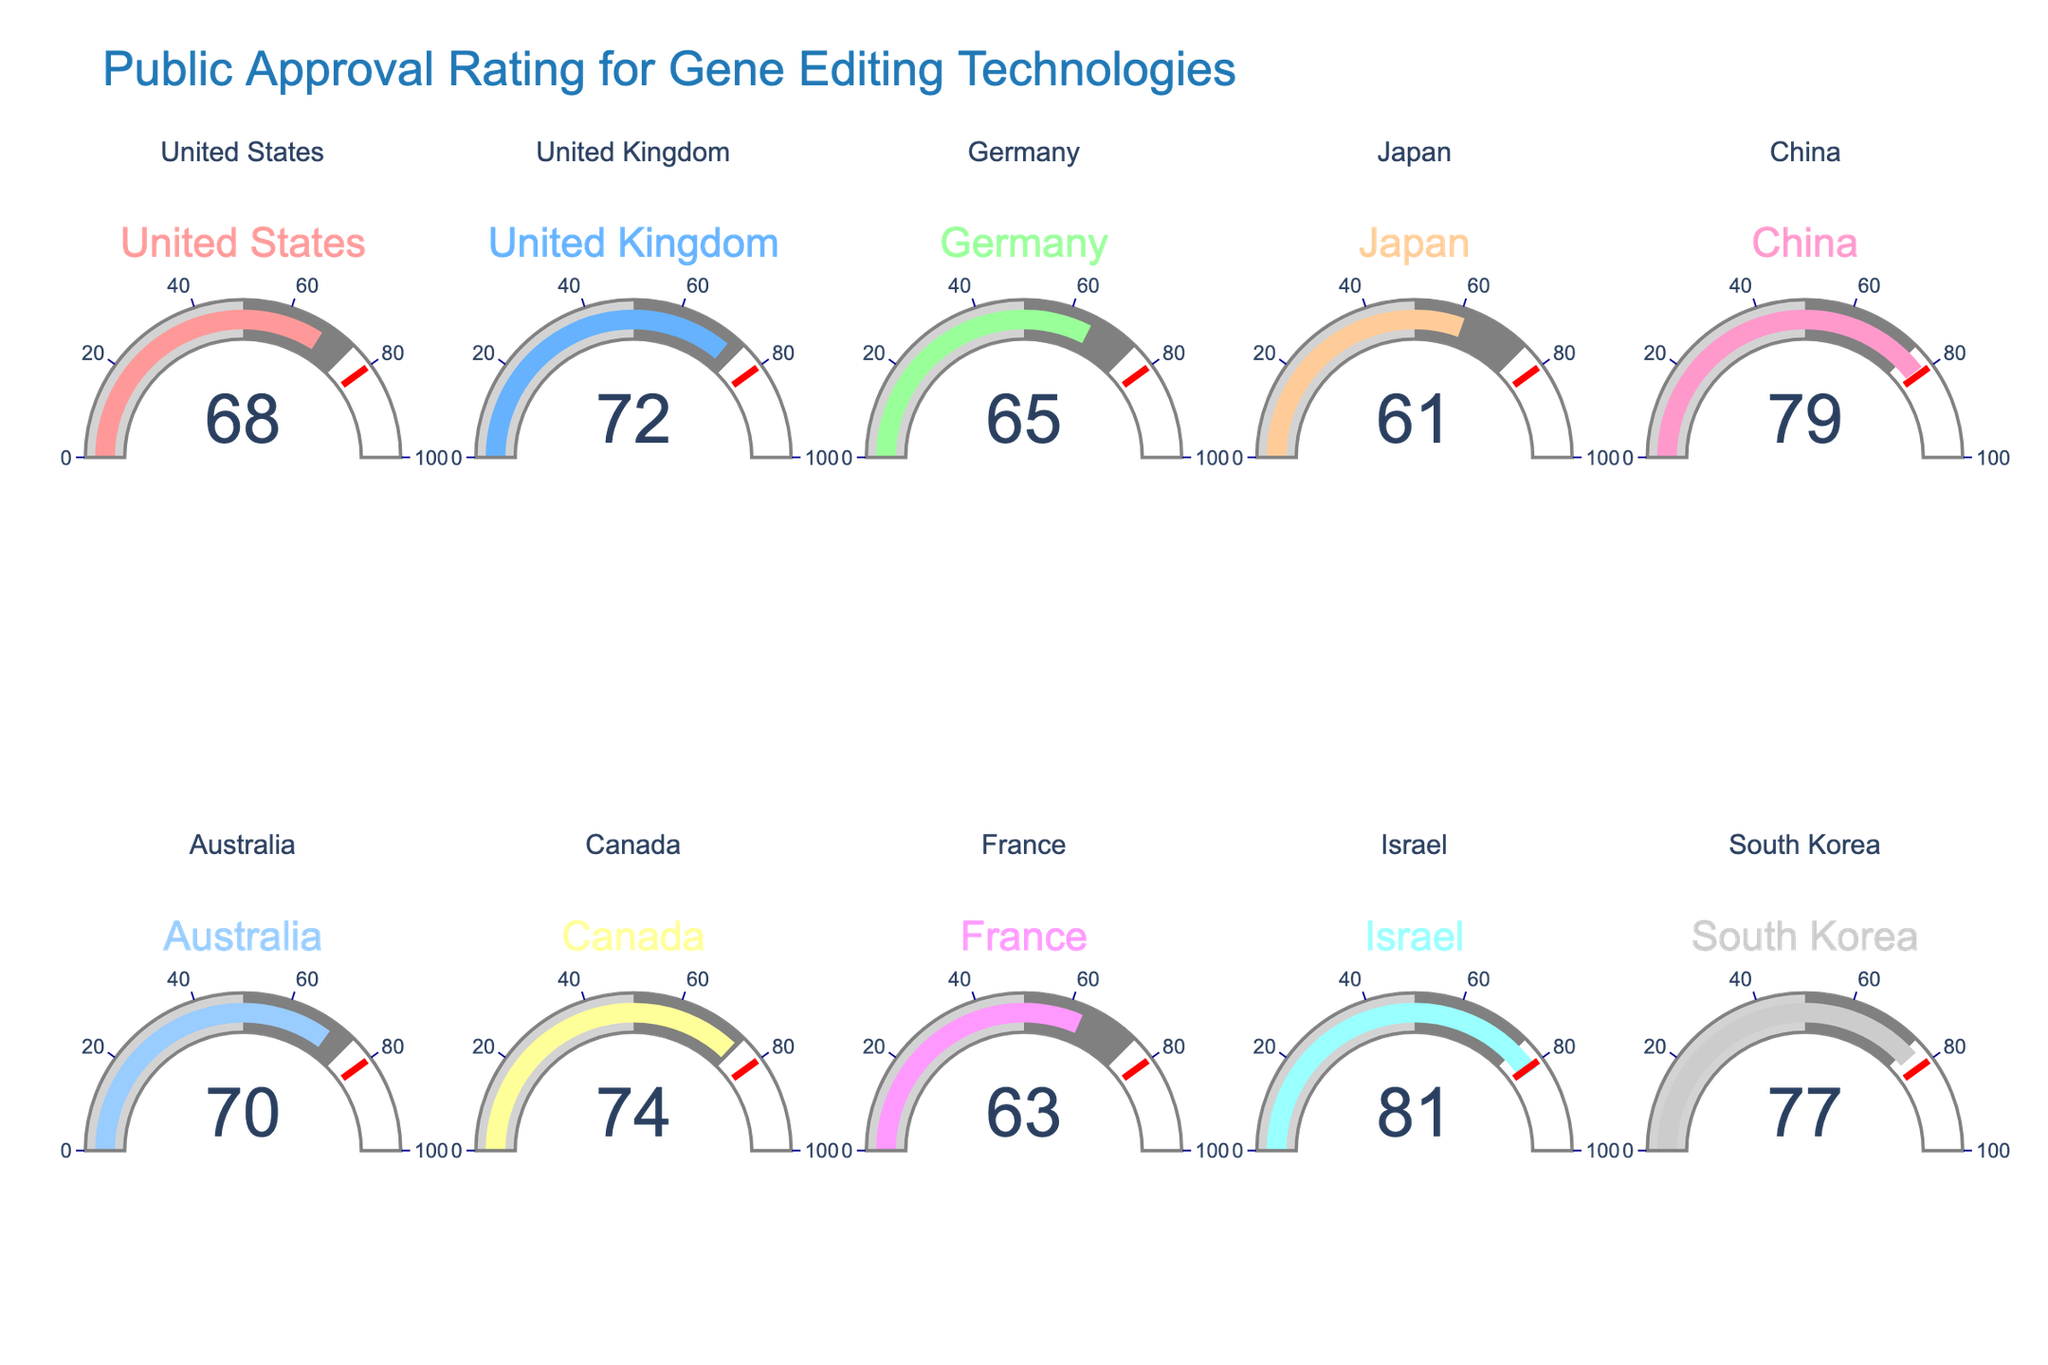What is the approval rating for gene editing technologies in the United States? The gauge for the United States shows a value of 68, representing the approval rating.
Answer: 68 Which country has the highest approval rating for gene editing technologies? By comparing all the gauges, Israel has the highest approval rating with a value of 81.
Answer: Israel What is the average approval rating across all listed countries? Sum of all approval percentages (68+72+65+61+79+70+74+63+81+77) = 710. The number of countries is 10. Average = 710/10 = 71
Answer: 71 How does Germany's approval rating compare to Japan's? Germany's approval rating is 65 while Japan's is 61. Germany's rating is higher.
Answer: Germany's rating is higher Is there any country with an approval rating between 60 and 65? By examining the gauges, Japan (61) and Germany (65) fall within this range.
Answer: Yes, Japan and Germany What is the difference between the highest and the lowest approval ratings? The highest approval rating is from Israel (81) and the lowest is Japan (61). Difference = 81 - 61 = 20
Answer: 20 Which countries have approval ratings above 75? The countries with gauges displaying values higher than 75 are China (79), Israel (81), and South Korea (77).
Answer: China, Israel, South Korea Is Canada's approval rating above or below the average rating? The average rating across all countries is 71. Canada's approval rating is 74, which is above the average.
Answer: Above What is the median approval rating for the listed countries? Ordered ratings: 61, 63, 65, 68, 70, 72, 74, 77, 79, 81. With 10 data points, the median is the average of the 5th and 6th values: (70+72)/2 = 71.
Answer: 71 Which country has the closest approval rating to the median? The median value is 71. The country with the closest value is Canada with a rating of 74.
Answer: Canada 